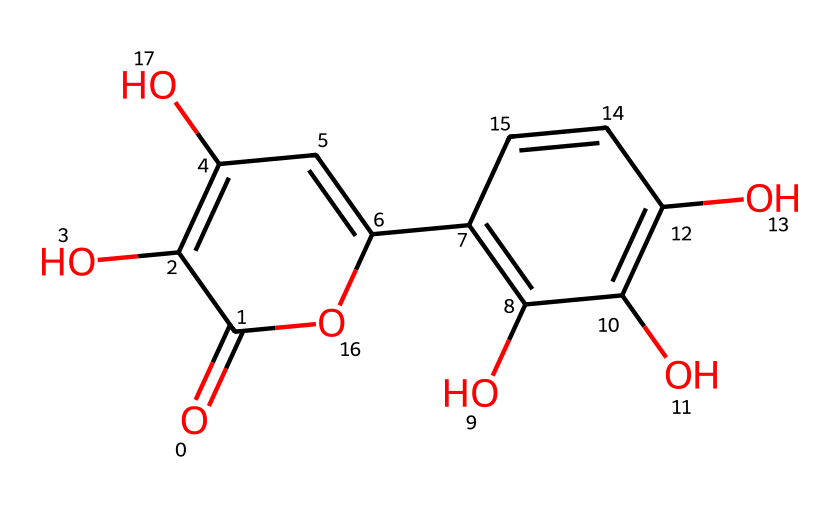What is the molecular formula of quercetin? By examining the structure represented in the SMILES notation, we can count the number of each type of atom present. The structure reveals 15 carbon atoms, 10 hydrogen atoms, and 7 oxygen atoms. Therefore, the molecular formula is C15H10O7.
Answer: C15H10O7 How many hydroxyl groups are present in quercetin? Looking at the chemical structure, we can identify hydroxyl groups (−OH) by locating the oxygen atoms bonded to hydrogen. There are three hydroxyl groups in the structure.
Answer: three What type of functional groups are present in quercetin? Analyzing the chemical structure, we notice that quercetin contains hydroxyl groups (−OH) as well as a ketone group (C=O). Both functional groups are characteristic of flavonoids and contribute to its properties as an antioxidant.
Answer: hydroxyl, ketone What is the largest ring structure in quercetin? In examining the chemical structure, there are two fused rings in the flavonoid skeleton. The larger ring contains six carbon atoms, making it a benzene-like structure, which forms part of the overall flavonoid framework.
Answer: benzene What role do quercetin's double bonds play in its antioxidant activity? The presence of double bonds in the structure allows for electron delocalization, which is critical for antioxidant activity. This delocalization stabilizes free radicals, enhancing quercetin's capacity to scavenge harmful oxidants in the body.
Answer: electron delocalization How does the structure of quercetin relate to its solubility in water? The hydroxyl groups present in the structure increase the polarity of quercetin, enhancing its solubility in water. The hydrogen bonding potential from these hydroxyl groups interacts favorably with water molecules.
Answer: increased polarity 